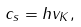<formula> <loc_0><loc_0><loc_500><loc_500>c _ { s } = h v _ { K } ,</formula> 